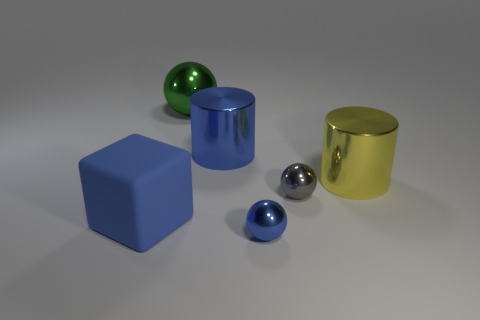Are there any other things that are made of the same material as the block?
Offer a terse response. No. How many objects are big shiny cylinders to the right of the blue sphere or spheres that are behind the tiny gray metal sphere?
Your answer should be compact. 2. How many objects are blue cylinders or green metallic things?
Provide a succinct answer. 2. There is a metal thing that is behind the small gray object and right of the large blue cylinder; what is its size?
Your answer should be compact. Large. How many cylinders have the same material as the tiny blue thing?
Offer a very short reply. 2. What color is the small thing that is made of the same material as the small blue ball?
Your response must be concise. Gray. Does the ball in front of the large blue rubber cube have the same color as the big rubber object?
Offer a terse response. Yes. There is a thing to the left of the large green thing; what is it made of?
Provide a succinct answer. Rubber. Is the number of tiny objects in front of the matte thing the same as the number of tiny cyan matte cylinders?
Your answer should be very brief. No. How many large metal things are the same color as the large rubber object?
Your answer should be very brief. 1. 